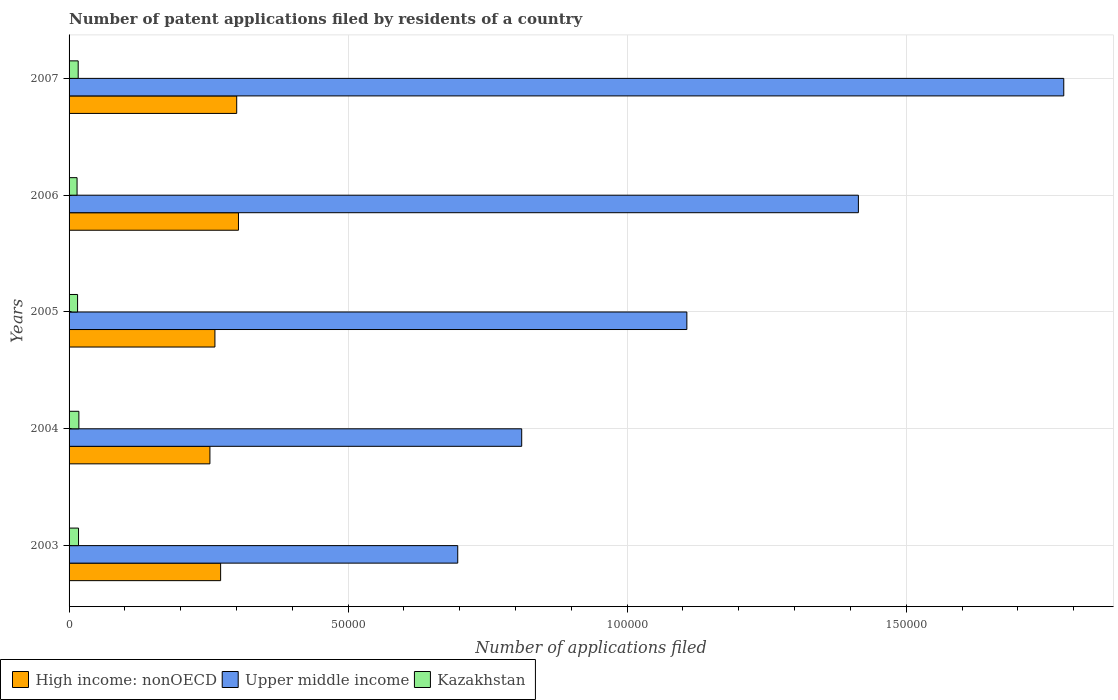How many groups of bars are there?
Make the answer very short. 5. Are the number of bars on each tick of the Y-axis equal?
Provide a short and direct response. Yes. How many bars are there on the 3rd tick from the top?
Offer a very short reply. 3. How many bars are there on the 3rd tick from the bottom?
Provide a succinct answer. 3. What is the label of the 3rd group of bars from the top?
Offer a very short reply. 2005. What is the number of applications filed in High income: nonOECD in 2004?
Your answer should be compact. 2.52e+04. Across all years, what is the maximum number of applications filed in Kazakhstan?
Your answer should be compact. 1756. Across all years, what is the minimum number of applications filed in Upper middle income?
Offer a very short reply. 6.96e+04. In which year was the number of applications filed in High income: nonOECD minimum?
Make the answer very short. 2004. What is the total number of applications filed in Upper middle income in the graph?
Offer a terse response. 5.81e+05. What is the difference between the number of applications filed in High income: nonOECD in 2003 and that in 2007?
Your response must be concise. -2880. What is the difference between the number of applications filed in Kazakhstan in 2007 and the number of applications filed in High income: nonOECD in 2003?
Keep it short and to the point. -2.55e+04. What is the average number of applications filed in High income: nonOECD per year?
Offer a very short reply. 2.78e+04. In the year 2005, what is the difference between the number of applications filed in Kazakhstan and number of applications filed in Upper middle income?
Provide a short and direct response. -1.09e+05. What is the ratio of the number of applications filed in Kazakhstan in 2004 to that in 2005?
Offer a very short reply. 1.15. What is the difference between the highest and the second highest number of applications filed in Upper middle income?
Your answer should be very brief. 3.68e+04. What is the difference between the highest and the lowest number of applications filed in Kazakhstan?
Your answer should be very brief. 323. In how many years, is the number of applications filed in Kazakhstan greater than the average number of applications filed in Kazakhstan taken over all years?
Make the answer very short. 3. Is the sum of the number of applications filed in High income: nonOECD in 2004 and 2007 greater than the maximum number of applications filed in Kazakhstan across all years?
Keep it short and to the point. Yes. What does the 1st bar from the top in 2004 represents?
Your response must be concise. Kazakhstan. What does the 3rd bar from the bottom in 2005 represents?
Ensure brevity in your answer.  Kazakhstan. How many bars are there?
Offer a very short reply. 15. Are all the bars in the graph horizontal?
Offer a terse response. Yes. Are the values on the major ticks of X-axis written in scientific E-notation?
Provide a succinct answer. No. Does the graph contain any zero values?
Keep it short and to the point. No. Does the graph contain grids?
Keep it short and to the point. Yes. Where does the legend appear in the graph?
Your answer should be compact. Bottom left. How are the legend labels stacked?
Your answer should be compact. Horizontal. What is the title of the graph?
Your answer should be very brief. Number of patent applications filed by residents of a country. What is the label or title of the X-axis?
Make the answer very short. Number of applications filed. What is the Number of applications filed of High income: nonOECD in 2003?
Offer a terse response. 2.72e+04. What is the Number of applications filed of Upper middle income in 2003?
Give a very brief answer. 6.96e+04. What is the Number of applications filed in Kazakhstan in 2003?
Offer a very short reply. 1696. What is the Number of applications filed of High income: nonOECD in 2004?
Your response must be concise. 2.52e+04. What is the Number of applications filed of Upper middle income in 2004?
Offer a very short reply. 8.11e+04. What is the Number of applications filed of Kazakhstan in 2004?
Your response must be concise. 1756. What is the Number of applications filed of High income: nonOECD in 2005?
Your answer should be very brief. 2.61e+04. What is the Number of applications filed of Upper middle income in 2005?
Make the answer very short. 1.11e+05. What is the Number of applications filed in Kazakhstan in 2005?
Ensure brevity in your answer.  1523. What is the Number of applications filed in High income: nonOECD in 2006?
Offer a terse response. 3.04e+04. What is the Number of applications filed in Upper middle income in 2006?
Give a very brief answer. 1.41e+05. What is the Number of applications filed of Kazakhstan in 2006?
Offer a terse response. 1433. What is the Number of applications filed in High income: nonOECD in 2007?
Make the answer very short. 3.00e+04. What is the Number of applications filed of Upper middle income in 2007?
Your answer should be compact. 1.78e+05. What is the Number of applications filed in Kazakhstan in 2007?
Provide a short and direct response. 1633. Across all years, what is the maximum Number of applications filed of High income: nonOECD?
Give a very brief answer. 3.04e+04. Across all years, what is the maximum Number of applications filed of Upper middle income?
Make the answer very short. 1.78e+05. Across all years, what is the maximum Number of applications filed of Kazakhstan?
Your answer should be very brief. 1756. Across all years, what is the minimum Number of applications filed in High income: nonOECD?
Provide a succinct answer. 2.52e+04. Across all years, what is the minimum Number of applications filed in Upper middle income?
Your response must be concise. 6.96e+04. Across all years, what is the minimum Number of applications filed of Kazakhstan?
Give a very brief answer. 1433. What is the total Number of applications filed of High income: nonOECD in the graph?
Provide a succinct answer. 1.39e+05. What is the total Number of applications filed in Upper middle income in the graph?
Your answer should be compact. 5.81e+05. What is the total Number of applications filed in Kazakhstan in the graph?
Ensure brevity in your answer.  8041. What is the difference between the Number of applications filed in High income: nonOECD in 2003 and that in 2004?
Offer a terse response. 1917. What is the difference between the Number of applications filed of Upper middle income in 2003 and that in 2004?
Ensure brevity in your answer.  -1.15e+04. What is the difference between the Number of applications filed of Kazakhstan in 2003 and that in 2004?
Your response must be concise. -60. What is the difference between the Number of applications filed of High income: nonOECD in 2003 and that in 2005?
Give a very brief answer. 1021. What is the difference between the Number of applications filed in Upper middle income in 2003 and that in 2005?
Ensure brevity in your answer.  -4.11e+04. What is the difference between the Number of applications filed in Kazakhstan in 2003 and that in 2005?
Ensure brevity in your answer.  173. What is the difference between the Number of applications filed of High income: nonOECD in 2003 and that in 2006?
Keep it short and to the point. -3198. What is the difference between the Number of applications filed of Upper middle income in 2003 and that in 2006?
Ensure brevity in your answer.  -7.18e+04. What is the difference between the Number of applications filed of Kazakhstan in 2003 and that in 2006?
Offer a very short reply. 263. What is the difference between the Number of applications filed of High income: nonOECD in 2003 and that in 2007?
Offer a very short reply. -2880. What is the difference between the Number of applications filed in Upper middle income in 2003 and that in 2007?
Your response must be concise. -1.09e+05. What is the difference between the Number of applications filed of Kazakhstan in 2003 and that in 2007?
Make the answer very short. 63. What is the difference between the Number of applications filed of High income: nonOECD in 2004 and that in 2005?
Ensure brevity in your answer.  -896. What is the difference between the Number of applications filed in Upper middle income in 2004 and that in 2005?
Give a very brief answer. -2.96e+04. What is the difference between the Number of applications filed in Kazakhstan in 2004 and that in 2005?
Give a very brief answer. 233. What is the difference between the Number of applications filed in High income: nonOECD in 2004 and that in 2006?
Your answer should be very brief. -5115. What is the difference between the Number of applications filed of Upper middle income in 2004 and that in 2006?
Your answer should be very brief. -6.03e+04. What is the difference between the Number of applications filed in Kazakhstan in 2004 and that in 2006?
Your response must be concise. 323. What is the difference between the Number of applications filed in High income: nonOECD in 2004 and that in 2007?
Ensure brevity in your answer.  -4797. What is the difference between the Number of applications filed in Upper middle income in 2004 and that in 2007?
Keep it short and to the point. -9.71e+04. What is the difference between the Number of applications filed in Kazakhstan in 2004 and that in 2007?
Your response must be concise. 123. What is the difference between the Number of applications filed in High income: nonOECD in 2005 and that in 2006?
Offer a very short reply. -4219. What is the difference between the Number of applications filed in Upper middle income in 2005 and that in 2006?
Give a very brief answer. -3.07e+04. What is the difference between the Number of applications filed in High income: nonOECD in 2005 and that in 2007?
Your answer should be very brief. -3901. What is the difference between the Number of applications filed in Upper middle income in 2005 and that in 2007?
Your answer should be very brief. -6.75e+04. What is the difference between the Number of applications filed of Kazakhstan in 2005 and that in 2007?
Your answer should be very brief. -110. What is the difference between the Number of applications filed in High income: nonOECD in 2006 and that in 2007?
Provide a short and direct response. 318. What is the difference between the Number of applications filed of Upper middle income in 2006 and that in 2007?
Give a very brief answer. -3.68e+04. What is the difference between the Number of applications filed in Kazakhstan in 2006 and that in 2007?
Provide a short and direct response. -200. What is the difference between the Number of applications filed of High income: nonOECD in 2003 and the Number of applications filed of Upper middle income in 2004?
Offer a very short reply. -5.39e+04. What is the difference between the Number of applications filed of High income: nonOECD in 2003 and the Number of applications filed of Kazakhstan in 2004?
Your response must be concise. 2.54e+04. What is the difference between the Number of applications filed in Upper middle income in 2003 and the Number of applications filed in Kazakhstan in 2004?
Provide a succinct answer. 6.79e+04. What is the difference between the Number of applications filed of High income: nonOECD in 2003 and the Number of applications filed of Upper middle income in 2005?
Your answer should be very brief. -8.35e+04. What is the difference between the Number of applications filed of High income: nonOECD in 2003 and the Number of applications filed of Kazakhstan in 2005?
Give a very brief answer. 2.56e+04. What is the difference between the Number of applications filed in Upper middle income in 2003 and the Number of applications filed in Kazakhstan in 2005?
Your answer should be compact. 6.81e+04. What is the difference between the Number of applications filed in High income: nonOECD in 2003 and the Number of applications filed in Upper middle income in 2006?
Give a very brief answer. -1.14e+05. What is the difference between the Number of applications filed in High income: nonOECD in 2003 and the Number of applications filed in Kazakhstan in 2006?
Give a very brief answer. 2.57e+04. What is the difference between the Number of applications filed in Upper middle income in 2003 and the Number of applications filed in Kazakhstan in 2006?
Provide a short and direct response. 6.82e+04. What is the difference between the Number of applications filed in High income: nonOECD in 2003 and the Number of applications filed in Upper middle income in 2007?
Offer a terse response. -1.51e+05. What is the difference between the Number of applications filed in High income: nonOECD in 2003 and the Number of applications filed in Kazakhstan in 2007?
Provide a succinct answer. 2.55e+04. What is the difference between the Number of applications filed of Upper middle income in 2003 and the Number of applications filed of Kazakhstan in 2007?
Keep it short and to the point. 6.80e+04. What is the difference between the Number of applications filed in High income: nonOECD in 2004 and the Number of applications filed in Upper middle income in 2005?
Your answer should be compact. -8.55e+04. What is the difference between the Number of applications filed of High income: nonOECD in 2004 and the Number of applications filed of Kazakhstan in 2005?
Keep it short and to the point. 2.37e+04. What is the difference between the Number of applications filed in Upper middle income in 2004 and the Number of applications filed in Kazakhstan in 2005?
Ensure brevity in your answer.  7.96e+04. What is the difference between the Number of applications filed in High income: nonOECD in 2004 and the Number of applications filed in Upper middle income in 2006?
Offer a terse response. -1.16e+05. What is the difference between the Number of applications filed of High income: nonOECD in 2004 and the Number of applications filed of Kazakhstan in 2006?
Provide a short and direct response. 2.38e+04. What is the difference between the Number of applications filed in Upper middle income in 2004 and the Number of applications filed in Kazakhstan in 2006?
Your answer should be very brief. 7.97e+04. What is the difference between the Number of applications filed in High income: nonOECD in 2004 and the Number of applications filed in Upper middle income in 2007?
Your answer should be very brief. -1.53e+05. What is the difference between the Number of applications filed of High income: nonOECD in 2004 and the Number of applications filed of Kazakhstan in 2007?
Provide a succinct answer. 2.36e+04. What is the difference between the Number of applications filed of Upper middle income in 2004 and the Number of applications filed of Kazakhstan in 2007?
Your answer should be compact. 7.95e+04. What is the difference between the Number of applications filed in High income: nonOECD in 2005 and the Number of applications filed in Upper middle income in 2006?
Ensure brevity in your answer.  -1.15e+05. What is the difference between the Number of applications filed of High income: nonOECD in 2005 and the Number of applications filed of Kazakhstan in 2006?
Your answer should be compact. 2.47e+04. What is the difference between the Number of applications filed in Upper middle income in 2005 and the Number of applications filed in Kazakhstan in 2006?
Your answer should be very brief. 1.09e+05. What is the difference between the Number of applications filed of High income: nonOECD in 2005 and the Number of applications filed of Upper middle income in 2007?
Your answer should be compact. -1.52e+05. What is the difference between the Number of applications filed in High income: nonOECD in 2005 and the Number of applications filed in Kazakhstan in 2007?
Ensure brevity in your answer.  2.45e+04. What is the difference between the Number of applications filed of Upper middle income in 2005 and the Number of applications filed of Kazakhstan in 2007?
Make the answer very short. 1.09e+05. What is the difference between the Number of applications filed in High income: nonOECD in 2006 and the Number of applications filed in Upper middle income in 2007?
Offer a terse response. -1.48e+05. What is the difference between the Number of applications filed of High income: nonOECD in 2006 and the Number of applications filed of Kazakhstan in 2007?
Provide a short and direct response. 2.87e+04. What is the difference between the Number of applications filed in Upper middle income in 2006 and the Number of applications filed in Kazakhstan in 2007?
Ensure brevity in your answer.  1.40e+05. What is the average Number of applications filed in High income: nonOECD per year?
Your answer should be very brief. 2.78e+04. What is the average Number of applications filed in Upper middle income per year?
Make the answer very short. 1.16e+05. What is the average Number of applications filed in Kazakhstan per year?
Provide a succinct answer. 1608.2. In the year 2003, what is the difference between the Number of applications filed of High income: nonOECD and Number of applications filed of Upper middle income?
Provide a succinct answer. -4.25e+04. In the year 2003, what is the difference between the Number of applications filed of High income: nonOECD and Number of applications filed of Kazakhstan?
Give a very brief answer. 2.55e+04. In the year 2003, what is the difference between the Number of applications filed of Upper middle income and Number of applications filed of Kazakhstan?
Keep it short and to the point. 6.79e+04. In the year 2004, what is the difference between the Number of applications filed in High income: nonOECD and Number of applications filed in Upper middle income?
Offer a very short reply. -5.59e+04. In the year 2004, what is the difference between the Number of applications filed of High income: nonOECD and Number of applications filed of Kazakhstan?
Offer a very short reply. 2.35e+04. In the year 2004, what is the difference between the Number of applications filed in Upper middle income and Number of applications filed in Kazakhstan?
Your answer should be compact. 7.93e+04. In the year 2005, what is the difference between the Number of applications filed of High income: nonOECD and Number of applications filed of Upper middle income?
Offer a terse response. -8.46e+04. In the year 2005, what is the difference between the Number of applications filed in High income: nonOECD and Number of applications filed in Kazakhstan?
Your response must be concise. 2.46e+04. In the year 2005, what is the difference between the Number of applications filed in Upper middle income and Number of applications filed in Kazakhstan?
Provide a succinct answer. 1.09e+05. In the year 2006, what is the difference between the Number of applications filed in High income: nonOECD and Number of applications filed in Upper middle income?
Ensure brevity in your answer.  -1.11e+05. In the year 2006, what is the difference between the Number of applications filed of High income: nonOECD and Number of applications filed of Kazakhstan?
Keep it short and to the point. 2.89e+04. In the year 2006, what is the difference between the Number of applications filed of Upper middle income and Number of applications filed of Kazakhstan?
Provide a succinct answer. 1.40e+05. In the year 2007, what is the difference between the Number of applications filed of High income: nonOECD and Number of applications filed of Upper middle income?
Provide a succinct answer. -1.48e+05. In the year 2007, what is the difference between the Number of applications filed in High income: nonOECD and Number of applications filed in Kazakhstan?
Offer a very short reply. 2.84e+04. In the year 2007, what is the difference between the Number of applications filed in Upper middle income and Number of applications filed in Kazakhstan?
Offer a very short reply. 1.77e+05. What is the ratio of the Number of applications filed in High income: nonOECD in 2003 to that in 2004?
Your answer should be very brief. 1.08. What is the ratio of the Number of applications filed of Upper middle income in 2003 to that in 2004?
Your answer should be very brief. 0.86. What is the ratio of the Number of applications filed of Kazakhstan in 2003 to that in 2004?
Your answer should be compact. 0.97. What is the ratio of the Number of applications filed of High income: nonOECD in 2003 to that in 2005?
Offer a terse response. 1.04. What is the ratio of the Number of applications filed of Upper middle income in 2003 to that in 2005?
Provide a short and direct response. 0.63. What is the ratio of the Number of applications filed of Kazakhstan in 2003 to that in 2005?
Your answer should be compact. 1.11. What is the ratio of the Number of applications filed of High income: nonOECD in 2003 to that in 2006?
Make the answer very short. 0.89. What is the ratio of the Number of applications filed in Upper middle income in 2003 to that in 2006?
Your response must be concise. 0.49. What is the ratio of the Number of applications filed in Kazakhstan in 2003 to that in 2006?
Your response must be concise. 1.18. What is the ratio of the Number of applications filed of High income: nonOECD in 2003 to that in 2007?
Offer a terse response. 0.9. What is the ratio of the Number of applications filed in Upper middle income in 2003 to that in 2007?
Give a very brief answer. 0.39. What is the ratio of the Number of applications filed in Kazakhstan in 2003 to that in 2007?
Offer a terse response. 1.04. What is the ratio of the Number of applications filed in High income: nonOECD in 2004 to that in 2005?
Provide a succinct answer. 0.97. What is the ratio of the Number of applications filed of Upper middle income in 2004 to that in 2005?
Keep it short and to the point. 0.73. What is the ratio of the Number of applications filed in Kazakhstan in 2004 to that in 2005?
Your answer should be compact. 1.15. What is the ratio of the Number of applications filed in High income: nonOECD in 2004 to that in 2006?
Offer a terse response. 0.83. What is the ratio of the Number of applications filed of Upper middle income in 2004 to that in 2006?
Your response must be concise. 0.57. What is the ratio of the Number of applications filed of Kazakhstan in 2004 to that in 2006?
Ensure brevity in your answer.  1.23. What is the ratio of the Number of applications filed of High income: nonOECD in 2004 to that in 2007?
Provide a succinct answer. 0.84. What is the ratio of the Number of applications filed in Upper middle income in 2004 to that in 2007?
Offer a terse response. 0.46. What is the ratio of the Number of applications filed of Kazakhstan in 2004 to that in 2007?
Your answer should be very brief. 1.08. What is the ratio of the Number of applications filed of High income: nonOECD in 2005 to that in 2006?
Give a very brief answer. 0.86. What is the ratio of the Number of applications filed of Upper middle income in 2005 to that in 2006?
Your answer should be compact. 0.78. What is the ratio of the Number of applications filed of Kazakhstan in 2005 to that in 2006?
Your response must be concise. 1.06. What is the ratio of the Number of applications filed in High income: nonOECD in 2005 to that in 2007?
Offer a terse response. 0.87. What is the ratio of the Number of applications filed in Upper middle income in 2005 to that in 2007?
Make the answer very short. 0.62. What is the ratio of the Number of applications filed in Kazakhstan in 2005 to that in 2007?
Provide a succinct answer. 0.93. What is the ratio of the Number of applications filed in High income: nonOECD in 2006 to that in 2007?
Your answer should be compact. 1.01. What is the ratio of the Number of applications filed of Upper middle income in 2006 to that in 2007?
Provide a short and direct response. 0.79. What is the ratio of the Number of applications filed of Kazakhstan in 2006 to that in 2007?
Give a very brief answer. 0.88. What is the difference between the highest and the second highest Number of applications filed in High income: nonOECD?
Provide a succinct answer. 318. What is the difference between the highest and the second highest Number of applications filed of Upper middle income?
Ensure brevity in your answer.  3.68e+04. What is the difference between the highest and the lowest Number of applications filed of High income: nonOECD?
Provide a short and direct response. 5115. What is the difference between the highest and the lowest Number of applications filed of Upper middle income?
Offer a terse response. 1.09e+05. What is the difference between the highest and the lowest Number of applications filed of Kazakhstan?
Give a very brief answer. 323. 